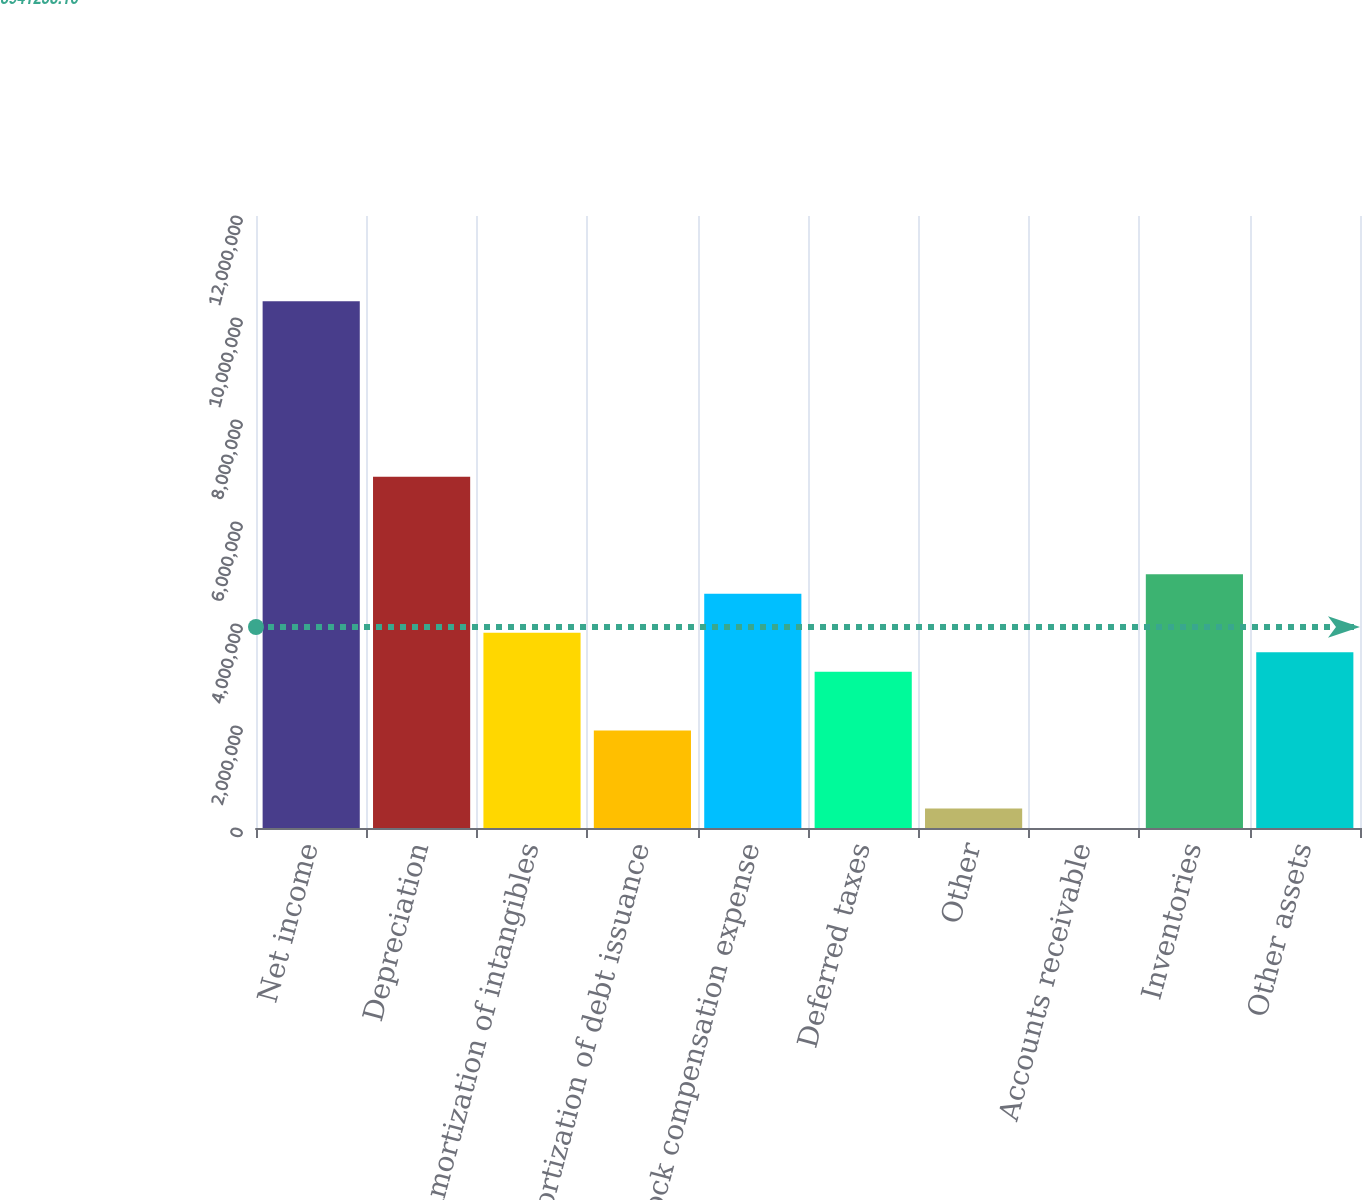Convert chart. <chart><loc_0><loc_0><loc_500><loc_500><bar_chart><fcel>Net income<fcel>Depreciation<fcel>Amortization of intangibles<fcel>Amortization of debt issuance<fcel>Stock compensation expense<fcel>Deferred taxes<fcel>Other<fcel>Accounts receivable<fcel>Inventories<fcel>Other assets<nl><fcel>1.03295e+07<fcel>6.88672e+06<fcel>3.8265e+06<fcel>1.91386e+06<fcel>4.59155e+06<fcel>3.06145e+06<fcel>383755<fcel>1228<fcel>4.97408e+06<fcel>3.44397e+06<nl></chart> 